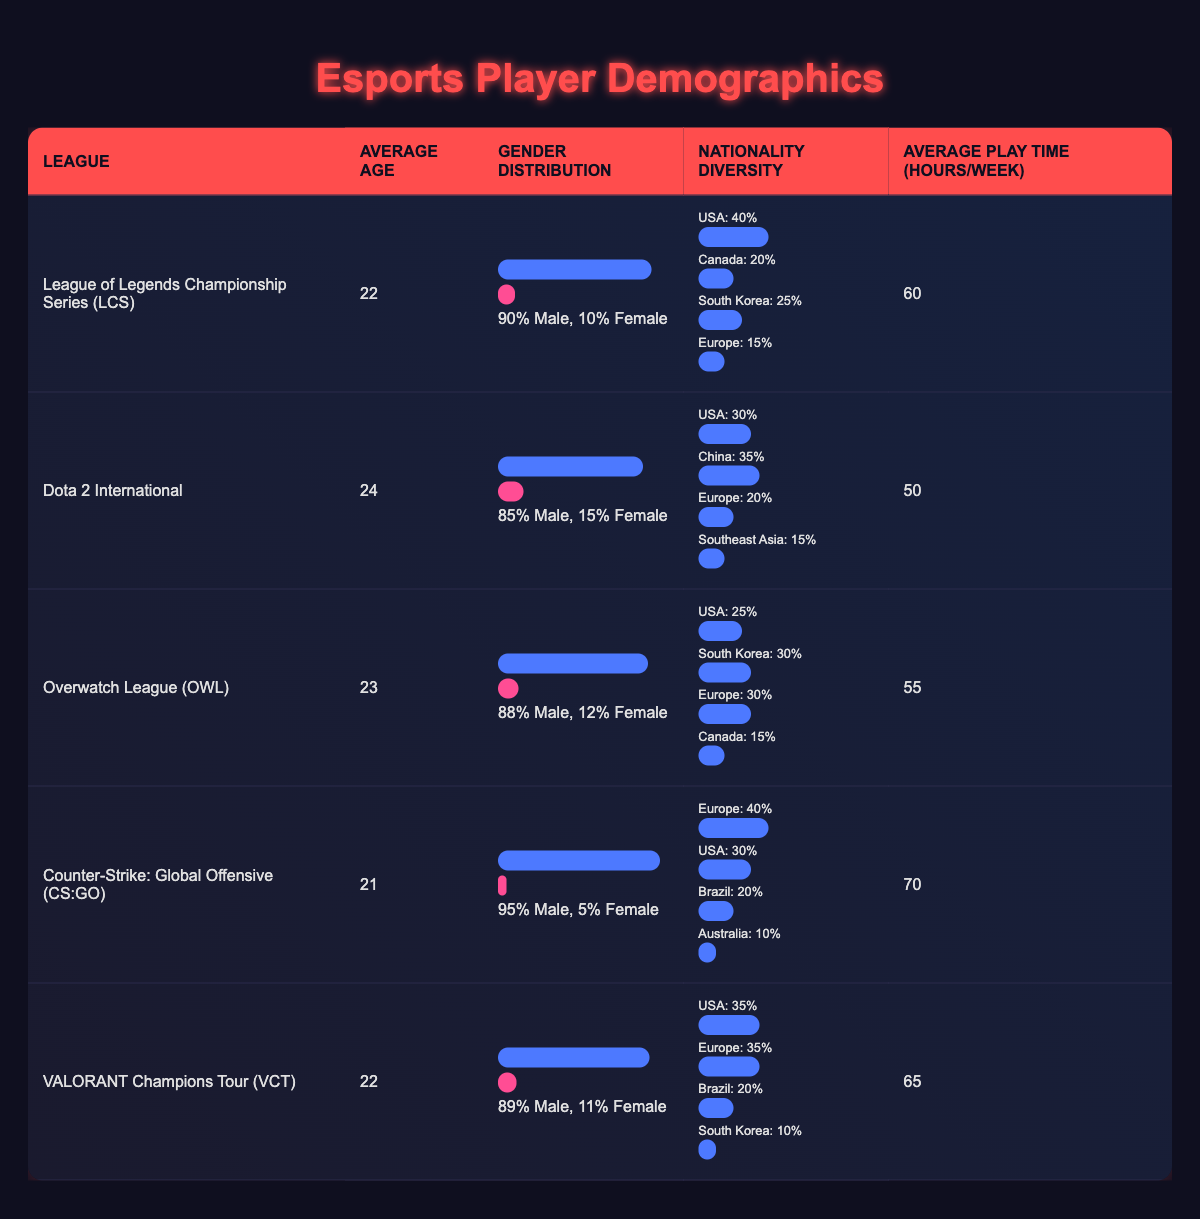What is the average age of players in the Overwatch League? The table provides a column for average age in various leagues. For the Overwatch League, it states the average age is 23.
Answer: 23 Which league has the highest percentage of female players? By comparing the gender distribution percentages, the Dota 2 International league has the highest percentage of female players at 15%.
Answer: Dota 2 International What is the total average play time per week for players across all leagues? To find the total average play time, we sum up the average play time for each league: 60 + 50 + 55 + 70 + 65 = 300. Then, we divide by the number of leagues, which is 5: 300/5 = 60.
Answer: 60 How many leagues have an average age of 22 or older? Checking the average ages, we see that LCS (22), Dota 2 International (24), Overwatch League (23), and VALORANT (22) all meet the criteria. This makes a total of 4 leagues.
Answer: 4 Are the majority of players in the CS:GO league male? Referring to the gender distribution for CS:GO, we see 95% of players are male, which indicates the majority.
Answer: Yes Which two nationalities have the highest diversity in the VALORANT Champions Tour? The nationality diversity for the VALORANT Champions Tour shows that USA and Europe each hold 35%, which are the highest percentages.
Answer: USA and Europe What is the average play time for players in the Counter-Strike: Global Offensive league? Looking at the average play time column, the average play time for players in CS:GO is stated as 70 hours per week.
Answer: 70 Is the female player percentage in the League of Legends Championship Series higher than in Overwatch League? For LCS, the percentage is 10% female, while Overwatch League has 12%. Since 12% is greater than 10%, the statement is true.
Answer: Yes If we combine the male player percentages for Dota 2 International and VALORANT Champions Tour, what is the total? The male percentage for Dota 2 International is 85% and for VALORANT is 89%. Combining these gives us 85 + 89 = 174%.
Answer: 174% 